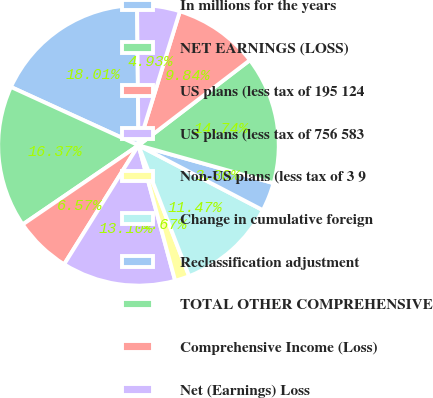<chart> <loc_0><loc_0><loc_500><loc_500><pie_chart><fcel>In millions for the years<fcel>NET EARNINGS (LOSS)<fcel>US plans (less tax of 195 124<fcel>US plans (less tax of 756 583<fcel>Non-US plans (less tax of 3 9<fcel>Change in cumulative foreign<fcel>Reclassification adjustment<fcel>TOTAL OTHER COMPREHENSIVE<fcel>Comprehensive Income (Loss)<fcel>Net (Earnings) Loss<nl><fcel>18.01%<fcel>16.37%<fcel>6.57%<fcel>13.1%<fcel>1.67%<fcel>11.47%<fcel>3.3%<fcel>14.74%<fcel>9.84%<fcel>4.93%<nl></chart> 